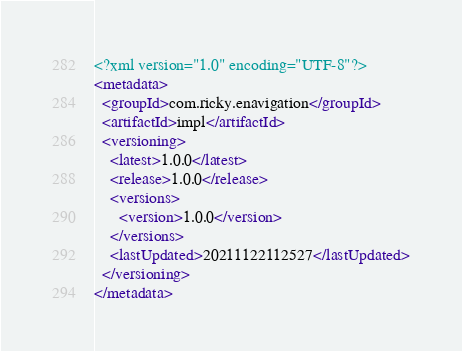Convert code to text. <code><loc_0><loc_0><loc_500><loc_500><_XML_><?xml version="1.0" encoding="UTF-8"?>
<metadata>
  <groupId>com.ricky.enavigation</groupId>
  <artifactId>impl</artifactId>
  <versioning>
    <latest>1.0.0</latest>
    <release>1.0.0</release>
    <versions>
      <version>1.0.0</version>
    </versions>
    <lastUpdated>20211122112527</lastUpdated>
  </versioning>
</metadata>
</code> 